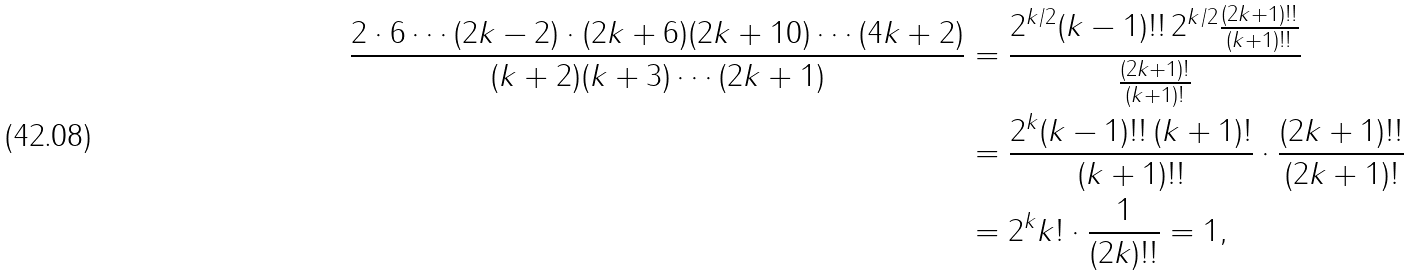<formula> <loc_0><loc_0><loc_500><loc_500>\frac { 2 \cdot 6 \cdots ( 2 k - 2 ) \cdot ( 2 k + 6 ) ( 2 k + 1 0 ) \cdots ( 4 k + 2 ) } { ( k + 2 ) ( k + 3 ) \cdots ( 2 k + 1 ) } & = \frac { 2 ^ { k / 2 } ( k - 1 ) ! ! \, 2 ^ { k / 2 } \frac { ( 2 k + 1 ) ! ! } { ( k + 1 ) ! ! } } { \frac { ( 2 k + 1 ) ! } { ( k + 1 ) ! } } \\ & = \frac { 2 ^ { k } ( k - 1 ) ! ! \, ( k + 1 ) ! } { ( k + 1 ) ! ! } \cdot \frac { ( 2 k + 1 ) ! ! } { ( 2 k + 1 ) ! } \\ & = 2 ^ { k } k ! \cdot \frac { 1 } { ( 2 k ) ! ! } = 1 ,</formula> 